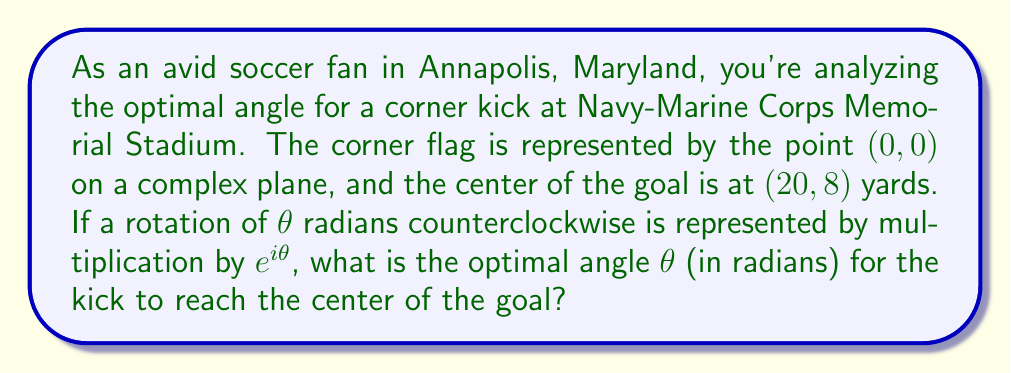Provide a solution to this math problem. Let's approach this step-by-step:

1) First, we need to represent the goal's center as a complex number. Given the coordinates (20,8), we can write this as:

   $z = 20 + 8i$

2) The optimal angle for the kick is the angle between the positive x-axis and the line from the corner flag to the goal's center. We can find this using the argument of the complex number $z$.

3) The argument of a complex number $a+bi$ is given by $\arctan(\frac{b}{a})$. However, we need to be careful to choose the correct quadrant.

4) In this case, we can use the two-argument arctangent function, $\arctan2(y,x)$, which takes care of the quadrant issue for us.

5) Therefore, the optimal angle $\theta$ is:

   $\theta = \arctan2(8, 20)$

6) We can calculate this:

   $\theta = \arctan2(8, 20) \approx 0.3805$ radians

7) To verify, we can use the rotation formula:

   $z' = ze^{-i\theta} = (20+8i)(\cos(-\theta) + i\sin(-\theta))$

   If $\theta$ is correct, the imaginary part of $z'$ should be zero.

8) Indeed, calculating $z'$ with our $\theta$:

   $z' \approx 21.5443 + 0i$

   The imaginary part is effectively zero (any small deviation is due to rounding in the approximation of $\theta$).

This confirms that our calculated $\theta$ is the optimal angle for the corner kick.
Answer: The optimal angle for the corner kick is approximately $0.3805$ radians (or about $21.8$ degrees). 